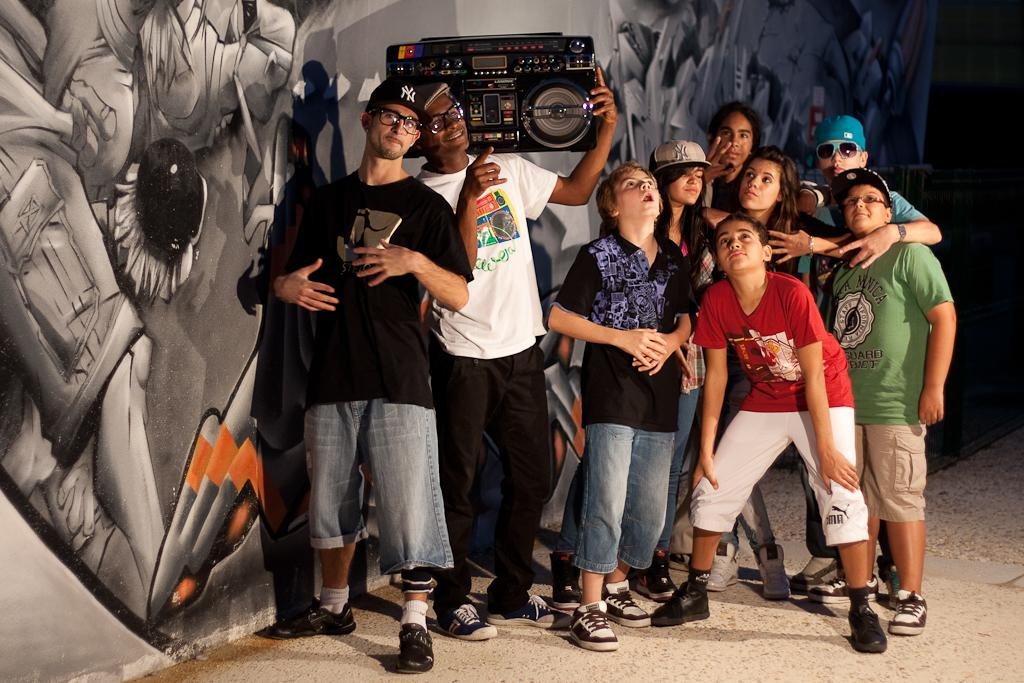How many people are in the image? There is a group of people in the image. What is the position of the people in the image? The people are standing on the ground. What is one person holding in their hand? One person is holding a device in their hand. What can be seen in the background of the image? There is a painting on the wall in the background of the image. How many things can be pulled out of the painting in the image? There are no things to be pulled out of the painting in the image, as it is a static image on the wall. 